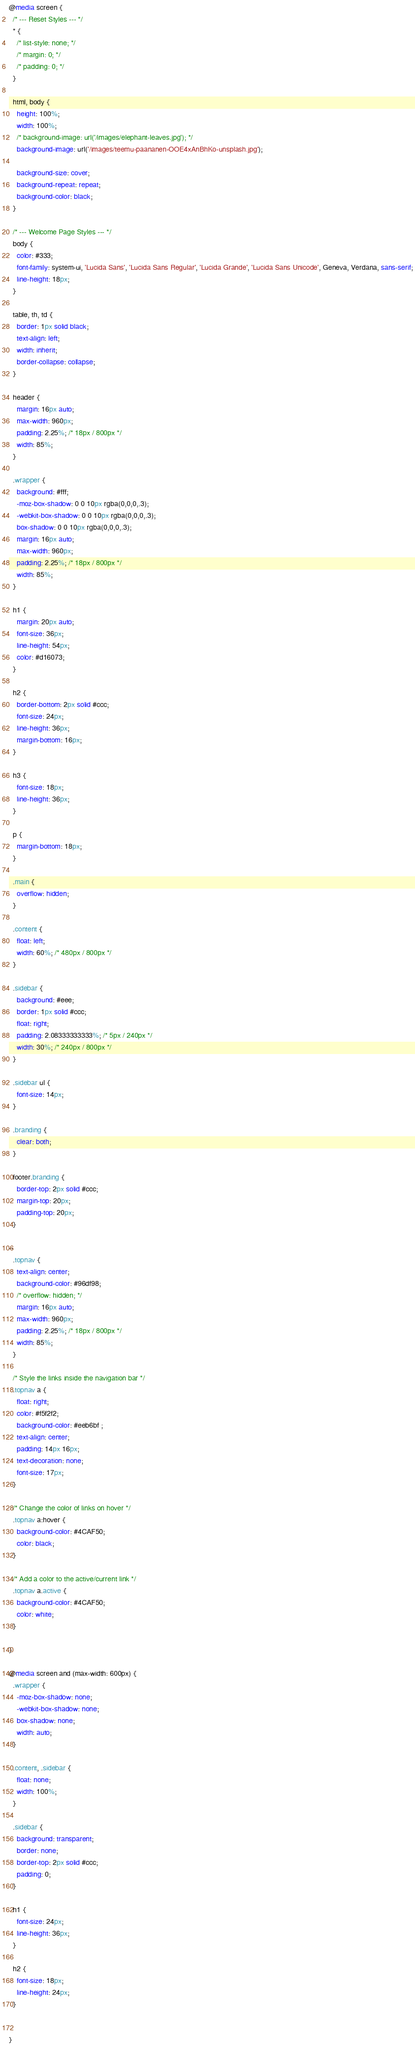Convert code to text. <code><loc_0><loc_0><loc_500><loc_500><_CSS_>@media screen {
  /* --- Reset Styles --- */
  * {
    /* list-style: none; */
    /* margin: 0; */
    /* padding: 0; */
  }

  html, body {
    height: 100%;
    width: 100%;
    /* background-image: url('/images/elephant-leaves.jpg'); */
    background-image: url('/images/teemu-paananen-OOE4xAnBhKo-unsplash.jpg');

    background-size: cover;
    background-repeat: repeat;
    background-color: black;
  }

  /* --- Welcome Page Styles --- */
  body {
    color: #333;
    font-family: system-ui, 'Lucida Sans', 'Lucida Sans Regular', 'Lucida Grande', 'Lucida Sans Unicode', Geneva, Verdana, sans-serif;
    line-height: 18px;
  }

  table, th, td {
    border: 1px solid black;
    text-align: left;
    width: inherit;
    border-collapse: collapse;
  }

  header {
    margin: 16px auto;
    max-width: 960px;
    padding: 2.25%; /* 18px / 800px */
    width: 85%;
  }

  .wrapper {
    background: #fff;
    -moz-box-shadow: 0 0 10px rgba(0,0,0,.3);
    -webkit-box-shadow: 0 0 10px rgba(0,0,0,.3);
    box-shadow: 0 0 10px rgba(0,0,0,.3);
    margin: 16px auto;
    max-width: 960px;
    padding: 2.25%; /* 18px / 800px */
    width: 85%;
  }

  h1 {
    margin: 20px auto;
    font-size: 36px;
    line-height: 54px;
    color: #d16073;
  }

  h2 {
    border-bottom: 2px solid #ccc;
    font-size: 24px;
    line-height: 36px;
    margin-bottom: 16px;
  }

  h3 {
    font-size: 18px;
    line-height: 36px;
  }

  p {
    margin-bottom: 18px;
  }

  .main {
    overflow: hidden;
  }

  .content {
    float: left;
    width: 60%; /* 480px / 800px */
  }

  .sidebar {
    background: #eee;
    border: 1px solid #ccc;
    float: right;
    padding: 2.08333333333%; /* 5px / 240px */
    width: 30%; /* 240px / 800px */
  }

  .sidebar ul {
    font-size: 14px;
  }

  .branding {
    clear: both;
  }

  footer.branding {
    border-top: 2px solid #ccc;
    margin-top: 20px;
    padding-top: 20px;
  }

--
  .topnav {
    text-align: center;
    background-color: #96df98;
    /* overflow: hidden; */
    margin: 16px auto;
    max-width: 960px;
    padding: 2.25%; /* 18px / 800px */
    width: 85%;
  }

  /* Style the links inside the navigation bar */
  .topnav a {
    float: right;
    color: #f5f2f2;
    background-color: #eeb6bf ;
    text-align: center;
    padding: 14px 16px;
    text-decoration: none;
    font-size: 17px;
  }

  /* Change the color of links on hover */
  .topnav a:hover {
    background-color: #4CAF50;
    color: black;
  }

  /* Add a color to the active/current link */
  .topnav a.active {
    background-color: #4CAF50;
    color: white;
  }

}

@media screen and (max-width: 600px) {
  .wrapper {
    -moz-box-shadow: none;
    -webkit-box-shadow: none;
    box-shadow: none;
    width: auto;
  }

  .content, .sidebar {
    float: none;
    width: 100%;
  }

  .sidebar {
    background: transparent;
    border: none;
    border-top: 2px solid #ccc;
    padding: 0;
  }

  h1 {
    font-size: 24px;
    line-height: 36px;
  }

  h2 {
    font-size: 18px;
    line-height: 24px;
  }


}
</code> 